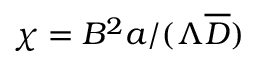Convert formula to latex. <formula><loc_0><loc_0><loc_500><loc_500>\chi = B ^ { 2 } a / ( \Lambda \overline { D } )</formula> 